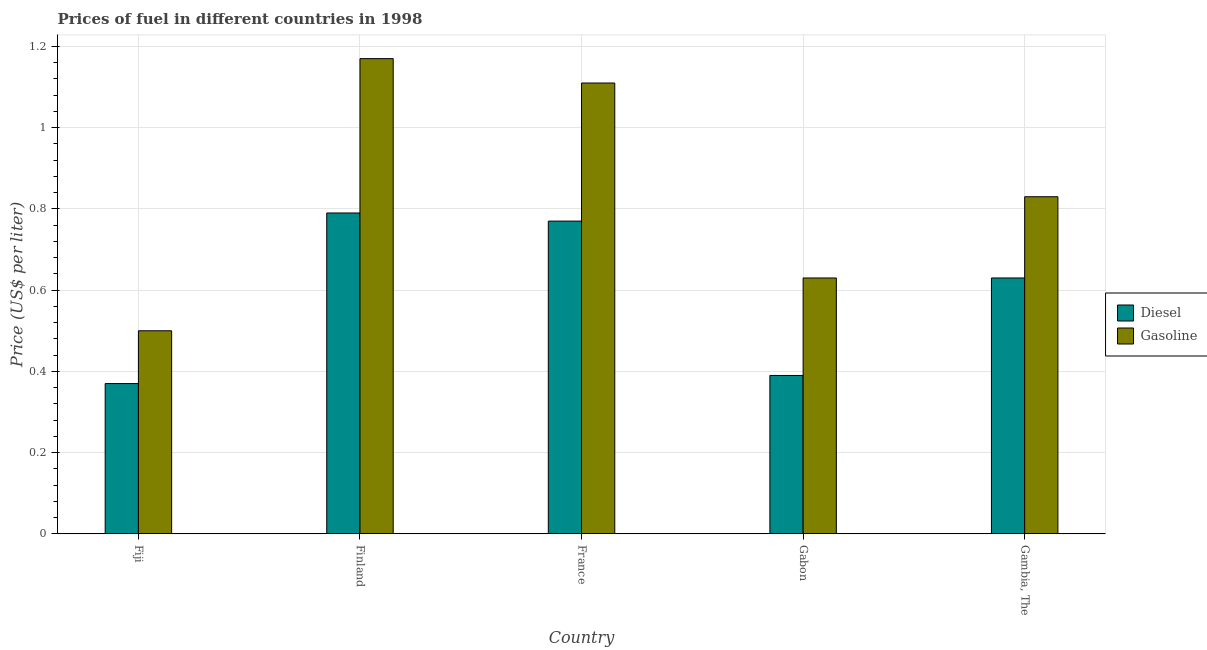How many groups of bars are there?
Give a very brief answer. 5. Are the number of bars per tick equal to the number of legend labels?
Make the answer very short. Yes. How many bars are there on the 4th tick from the left?
Your answer should be very brief. 2. What is the label of the 5th group of bars from the left?
Give a very brief answer. Gambia, The. What is the gasoline price in Gabon?
Offer a terse response. 0.63. Across all countries, what is the maximum gasoline price?
Your answer should be very brief. 1.17. In which country was the gasoline price minimum?
Your answer should be compact. Fiji. What is the total gasoline price in the graph?
Ensure brevity in your answer.  4.24. What is the difference between the diesel price in Fiji and that in Finland?
Offer a terse response. -0.42. What is the difference between the gasoline price in France and the diesel price in Finland?
Your response must be concise. 0.32. What is the average diesel price per country?
Offer a terse response. 0.59. What is the difference between the diesel price and gasoline price in Finland?
Your answer should be very brief. -0.38. What is the ratio of the diesel price in Fiji to that in Gambia, The?
Your answer should be very brief. 0.59. Is the difference between the diesel price in Fiji and Finland greater than the difference between the gasoline price in Fiji and Finland?
Offer a very short reply. Yes. What is the difference between the highest and the second highest gasoline price?
Provide a succinct answer. 0.06. What is the difference between the highest and the lowest gasoline price?
Ensure brevity in your answer.  0.67. In how many countries, is the diesel price greater than the average diesel price taken over all countries?
Offer a very short reply. 3. What does the 2nd bar from the left in Gambia, The represents?
Keep it short and to the point. Gasoline. What does the 1st bar from the right in Finland represents?
Your response must be concise. Gasoline. How many bars are there?
Make the answer very short. 10. Are the values on the major ticks of Y-axis written in scientific E-notation?
Ensure brevity in your answer.  No. Does the graph contain any zero values?
Offer a terse response. No. Does the graph contain grids?
Keep it short and to the point. Yes. How many legend labels are there?
Keep it short and to the point. 2. How are the legend labels stacked?
Provide a succinct answer. Vertical. What is the title of the graph?
Your answer should be compact. Prices of fuel in different countries in 1998. What is the label or title of the X-axis?
Your response must be concise. Country. What is the label or title of the Y-axis?
Provide a succinct answer. Price (US$ per liter). What is the Price (US$ per liter) of Diesel in Fiji?
Your response must be concise. 0.37. What is the Price (US$ per liter) in Gasoline in Fiji?
Offer a terse response. 0.5. What is the Price (US$ per liter) of Diesel in Finland?
Offer a very short reply. 0.79. What is the Price (US$ per liter) in Gasoline in Finland?
Offer a very short reply. 1.17. What is the Price (US$ per liter) of Diesel in France?
Keep it short and to the point. 0.77. What is the Price (US$ per liter) in Gasoline in France?
Your answer should be very brief. 1.11. What is the Price (US$ per liter) in Diesel in Gabon?
Make the answer very short. 0.39. What is the Price (US$ per liter) in Gasoline in Gabon?
Offer a terse response. 0.63. What is the Price (US$ per liter) of Diesel in Gambia, The?
Give a very brief answer. 0.63. What is the Price (US$ per liter) in Gasoline in Gambia, The?
Make the answer very short. 0.83. Across all countries, what is the maximum Price (US$ per liter) in Diesel?
Your answer should be very brief. 0.79. Across all countries, what is the maximum Price (US$ per liter) of Gasoline?
Your answer should be very brief. 1.17. Across all countries, what is the minimum Price (US$ per liter) in Diesel?
Your answer should be very brief. 0.37. What is the total Price (US$ per liter) in Diesel in the graph?
Your answer should be compact. 2.95. What is the total Price (US$ per liter) in Gasoline in the graph?
Offer a terse response. 4.24. What is the difference between the Price (US$ per liter) in Diesel in Fiji and that in Finland?
Make the answer very short. -0.42. What is the difference between the Price (US$ per liter) in Gasoline in Fiji and that in Finland?
Your answer should be very brief. -0.67. What is the difference between the Price (US$ per liter) in Gasoline in Fiji and that in France?
Keep it short and to the point. -0.61. What is the difference between the Price (US$ per liter) in Diesel in Fiji and that in Gabon?
Provide a short and direct response. -0.02. What is the difference between the Price (US$ per liter) of Gasoline in Fiji and that in Gabon?
Offer a terse response. -0.13. What is the difference between the Price (US$ per liter) of Diesel in Fiji and that in Gambia, The?
Your answer should be very brief. -0.26. What is the difference between the Price (US$ per liter) of Gasoline in Fiji and that in Gambia, The?
Give a very brief answer. -0.33. What is the difference between the Price (US$ per liter) of Diesel in Finland and that in France?
Give a very brief answer. 0.02. What is the difference between the Price (US$ per liter) in Gasoline in Finland and that in France?
Your response must be concise. 0.06. What is the difference between the Price (US$ per liter) of Diesel in Finland and that in Gabon?
Make the answer very short. 0.4. What is the difference between the Price (US$ per liter) in Gasoline in Finland and that in Gabon?
Keep it short and to the point. 0.54. What is the difference between the Price (US$ per liter) in Diesel in Finland and that in Gambia, The?
Your response must be concise. 0.16. What is the difference between the Price (US$ per liter) of Gasoline in Finland and that in Gambia, The?
Give a very brief answer. 0.34. What is the difference between the Price (US$ per liter) of Diesel in France and that in Gabon?
Ensure brevity in your answer.  0.38. What is the difference between the Price (US$ per liter) of Gasoline in France and that in Gabon?
Give a very brief answer. 0.48. What is the difference between the Price (US$ per liter) in Diesel in France and that in Gambia, The?
Offer a very short reply. 0.14. What is the difference between the Price (US$ per liter) in Gasoline in France and that in Gambia, The?
Keep it short and to the point. 0.28. What is the difference between the Price (US$ per liter) of Diesel in Gabon and that in Gambia, The?
Provide a short and direct response. -0.24. What is the difference between the Price (US$ per liter) in Gasoline in Gabon and that in Gambia, The?
Keep it short and to the point. -0.2. What is the difference between the Price (US$ per liter) of Diesel in Fiji and the Price (US$ per liter) of Gasoline in Finland?
Your response must be concise. -0.8. What is the difference between the Price (US$ per liter) in Diesel in Fiji and the Price (US$ per liter) in Gasoline in France?
Your answer should be compact. -0.74. What is the difference between the Price (US$ per liter) of Diesel in Fiji and the Price (US$ per liter) of Gasoline in Gabon?
Your answer should be compact. -0.26. What is the difference between the Price (US$ per liter) in Diesel in Fiji and the Price (US$ per liter) in Gasoline in Gambia, The?
Offer a very short reply. -0.46. What is the difference between the Price (US$ per liter) of Diesel in Finland and the Price (US$ per liter) of Gasoline in France?
Your answer should be compact. -0.32. What is the difference between the Price (US$ per liter) in Diesel in Finland and the Price (US$ per liter) in Gasoline in Gabon?
Provide a short and direct response. 0.16. What is the difference between the Price (US$ per liter) of Diesel in Finland and the Price (US$ per liter) of Gasoline in Gambia, The?
Ensure brevity in your answer.  -0.04. What is the difference between the Price (US$ per liter) in Diesel in France and the Price (US$ per liter) in Gasoline in Gabon?
Your answer should be very brief. 0.14. What is the difference between the Price (US$ per liter) of Diesel in France and the Price (US$ per liter) of Gasoline in Gambia, The?
Make the answer very short. -0.06. What is the difference between the Price (US$ per liter) in Diesel in Gabon and the Price (US$ per liter) in Gasoline in Gambia, The?
Your answer should be compact. -0.44. What is the average Price (US$ per liter) of Diesel per country?
Keep it short and to the point. 0.59. What is the average Price (US$ per liter) of Gasoline per country?
Your answer should be compact. 0.85. What is the difference between the Price (US$ per liter) of Diesel and Price (US$ per liter) of Gasoline in Fiji?
Offer a very short reply. -0.13. What is the difference between the Price (US$ per liter) of Diesel and Price (US$ per liter) of Gasoline in Finland?
Your answer should be very brief. -0.38. What is the difference between the Price (US$ per liter) in Diesel and Price (US$ per liter) in Gasoline in France?
Offer a terse response. -0.34. What is the difference between the Price (US$ per liter) in Diesel and Price (US$ per liter) in Gasoline in Gabon?
Offer a terse response. -0.24. What is the difference between the Price (US$ per liter) of Diesel and Price (US$ per liter) of Gasoline in Gambia, The?
Make the answer very short. -0.2. What is the ratio of the Price (US$ per liter) in Diesel in Fiji to that in Finland?
Give a very brief answer. 0.47. What is the ratio of the Price (US$ per liter) of Gasoline in Fiji to that in Finland?
Make the answer very short. 0.43. What is the ratio of the Price (US$ per liter) of Diesel in Fiji to that in France?
Your answer should be very brief. 0.48. What is the ratio of the Price (US$ per liter) of Gasoline in Fiji to that in France?
Ensure brevity in your answer.  0.45. What is the ratio of the Price (US$ per liter) in Diesel in Fiji to that in Gabon?
Offer a terse response. 0.95. What is the ratio of the Price (US$ per liter) of Gasoline in Fiji to that in Gabon?
Ensure brevity in your answer.  0.79. What is the ratio of the Price (US$ per liter) of Diesel in Fiji to that in Gambia, The?
Offer a very short reply. 0.59. What is the ratio of the Price (US$ per liter) of Gasoline in Fiji to that in Gambia, The?
Offer a very short reply. 0.6. What is the ratio of the Price (US$ per liter) in Diesel in Finland to that in France?
Your response must be concise. 1.03. What is the ratio of the Price (US$ per liter) of Gasoline in Finland to that in France?
Offer a terse response. 1.05. What is the ratio of the Price (US$ per liter) of Diesel in Finland to that in Gabon?
Provide a short and direct response. 2.03. What is the ratio of the Price (US$ per liter) of Gasoline in Finland to that in Gabon?
Give a very brief answer. 1.86. What is the ratio of the Price (US$ per liter) in Diesel in Finland to that in Gambia, The?
Offer a terse response. 1.25. What is the ratio of the Price (US$ per liter) in Gasoline in Finland to that in Gambia, The?
Keep it short and to the point. 1.41. What is the ratio of the Price (US$ per liter) of Diesel in France to that in Gabon?
Make the answer very short. 1.97. What is the ratio of the Price (US$ per liter) in Gasoline in France to that in Gabon?
Ensure brevity in your answer.  1.76. What is the ratio of the Price (US$ per liter) in Diesel in France to that in Gambia, The?
Make the answer very short. 1.22. What is the ratio of the Price (US$ per liter) of Gasoline in France to that in Gambia, The?
Your answer should be very brief. 1.34. What is the ratio of the Price (US$ per liter) in Diesel in Gabon to that in Gambia, The?
Offer a terse response. 0.62. What is the ratio of the Price (US$ per liter) in Gasoline in Gabon to that in Gambia, The?
Your answer should be compact. 0.76. What is the difference between the highest and the lowest Price (US$ per liter) in Diesel?
Make the answer very short. 0.42. What is the difference between the highest and the lowest Price (US$ per liter) of Gasoline?
Provide a succinct answer. 0.67. 